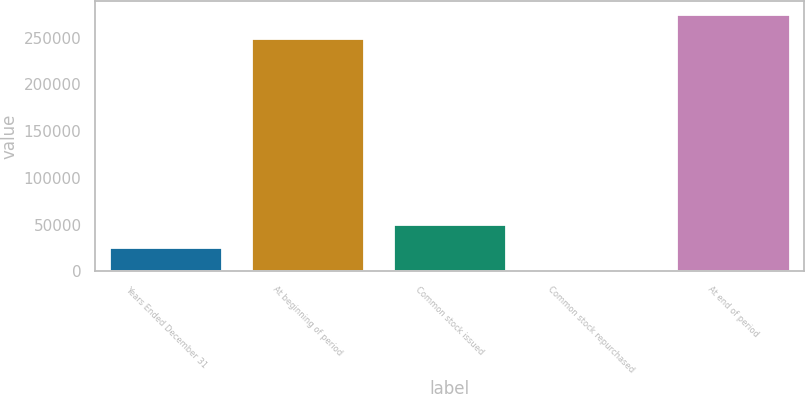Convert chart. <chart><loc_0><loc_0><loc_500><loc_500><bar_chart><fcel>Years Ended December 31<fcel>At beginning of period<fcel>Common stock issued<fcel>Common stock repurchased<fcel>At end of period<nl><fcel>25700.7<fcel>249628<fcel>51078.4<fcel>323<fcel>275006<nl></chart> 